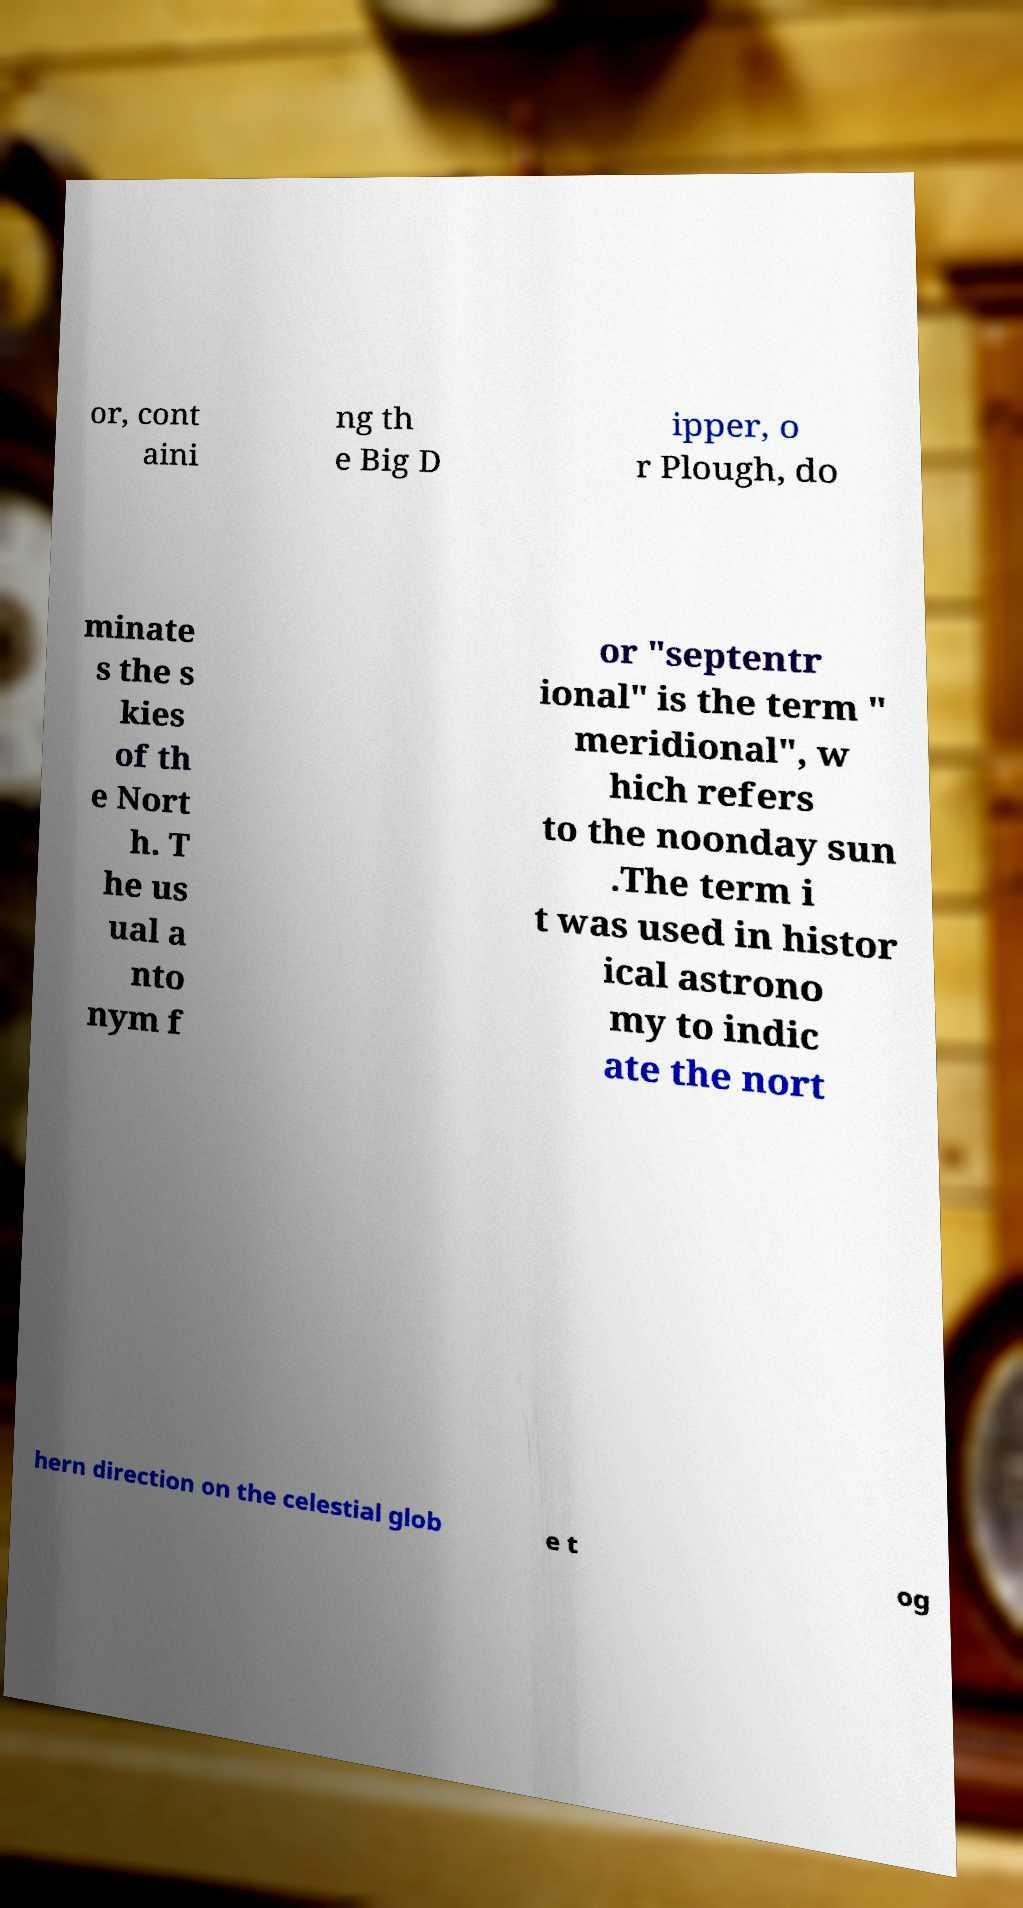Can you accurately transcribe the text from the provided image for me? or, cont aini ng th e Big D ipper, o r Plough, do minate s the s kies of th e Nort h. T he us ual a nto nym f or "septentr ional" is the term " meridional", w hich refers to the noonday sun .The term i t was used in histor ical astrono my to indic ate the nort hern direction on the celestial glob e t og 